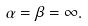Convert formula to latex. <formula><loc_0><loc_0><loc_500><loc_500>\alpha = \beta = \infty .</formula> 